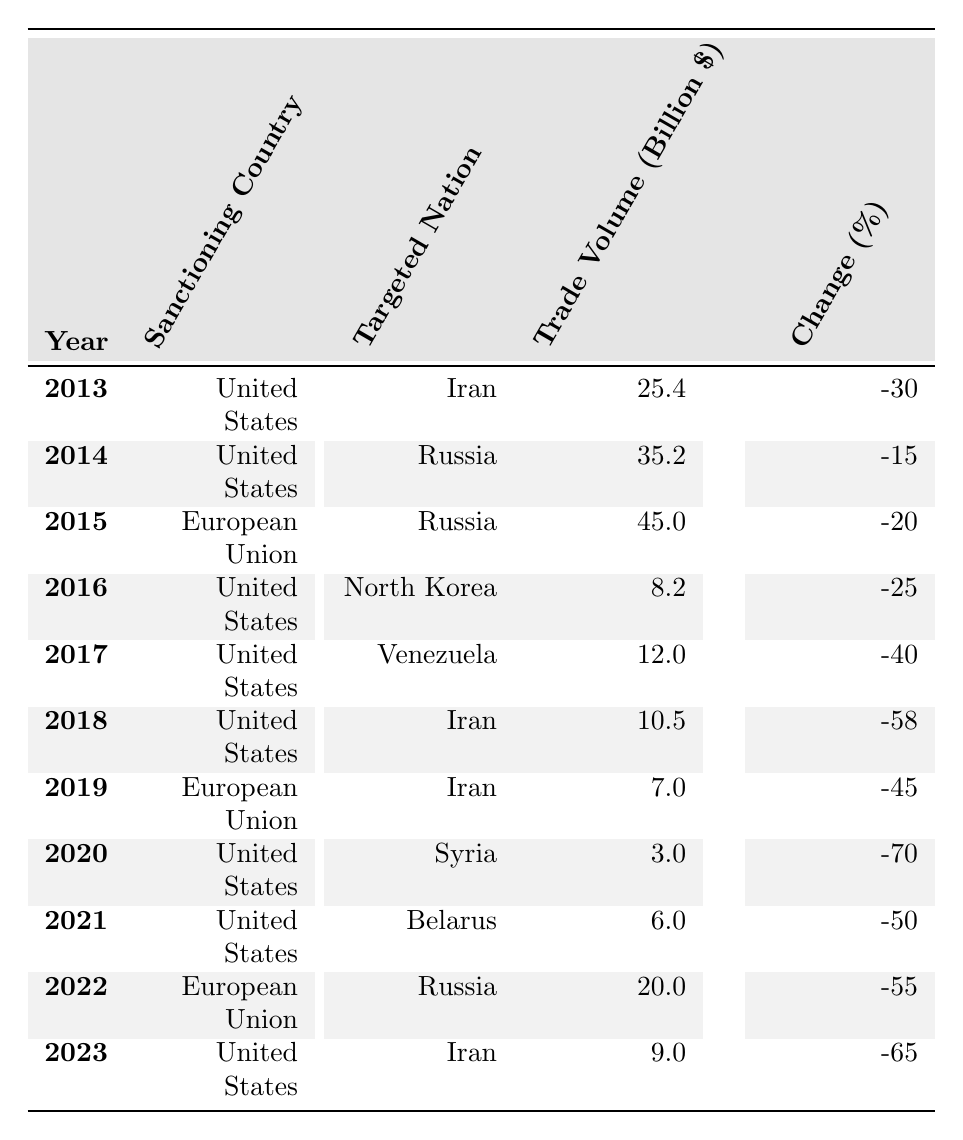What was the trade volume between the United States and Iran in 2013? The table shows the trade volume between the United States and Iran in 2013 as 25.4 billion dollars.
Answer: 25.4 billion dollars Which year saw the highest change percentage in trade volume for sanctions against Syria? The table contains data for sanctions against Syria only in 2020, with a change percentage of -70%. Therefore, this is the highest change percentage for this category.
Answer: -70% What was the trade volume change percentage for the European Union against Russia in 2022? The table indicates that the trade volume change percentage for the European Union against Russia in 2022 is -55%.
Answer: -55% Did the trade volume between the United States and Venezuela increase over the years listed? The table shows that the trade volume decreased from 12.0 billion dollars in 2017 to 0 in the years following, indicating a decline. Therefore, it did not increase.
Answer: No What is the average trade volume for the United States against Iran over the years it is listed? The trade volumes for the United States against Iran are 25.4 (2013), 10.5 (2018), and 9.0 (2023). The sum of these values is 25.4 + 10.5 + 9.0 = 44.9 billion dollars. There are 3 data points, so the average is 44.9 / 3 = 14.97 billion dollars.
Answer: 14.97 billion dollars Which targeted nation experienced the most significant drop in trade volume due to sanctions in 2020 compared to previous years? The table indicates that trade volume with Syria in 2020 was 3.0 billion dollars with a change percentage of -70%. Since no previous years appear in the table for Syria, we conclude this drop is significant as it's the only entry.
Answer: Syria Which sanctioning country had the most consistent negative change percentage against Iran across multiple years? The United States sanctioned Iran in 2013, 2018, and 2023, with change percentages of -30%, -58%, and -65%, respectively. All years show a negative change, indicating consistent sanctions and increasing severity.
Answer: United States What is the difference in trade volume between sanctions against North Korea and Belarus in 2021? The trade volume against North Korea in 2016 was 8.2 billion dollars, while the trade volume for Belarus in 2021 was 6.0 billion dollars. The difference is 8.2 - 6.0 = 2.2 billion dollars.
Answer: 2.2 billion dollars Which targeted nation consistently appeared in the table with declining trade volumes from the United States? Iran appears in 2013 (25.4), 2018 (10.5), and 2023 (9.0), showing a consistent decline in trade volumes over the years.
Answer: Iran In which year did the trade volume decrease the most significantly for the United States against any nation? The largest decrease was for Syria in 2020, with a trade volume of 3.0 billion dollars and a change percentage of -70%, reflecting the most significant decline.
Answer: 2020 What is the total trade volume change percentage of the European Union's trade with Iran across the years listed? The change percentages for the European Union's trade with Iran are -45% (2019). Since there are no other years listed, the total remains the same as there are no additional entries to sum.
Answer: -45% 